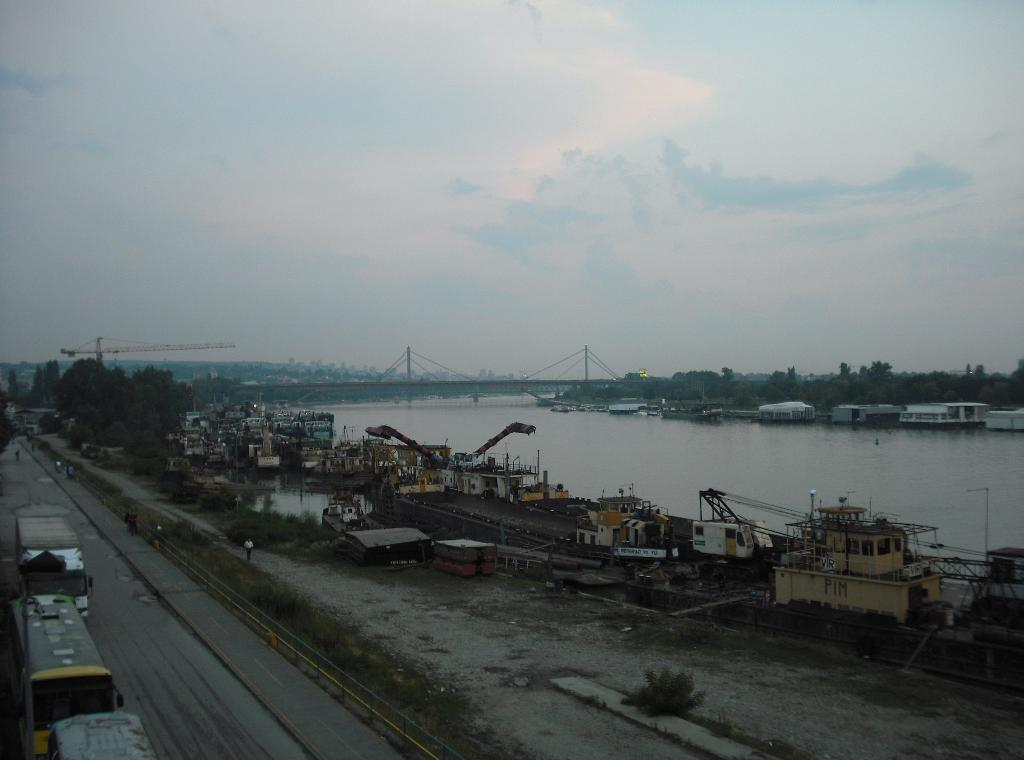What can be seen on the road in the image? There are vehicles on the road in the image. What type of natural environment is visible in the image? There is grass, trees, and water visible in the image. What type of construction equipment is present in the image? There are cranes in the image. What type of cargo containers are present in the image? Containers are present in the image. What type of man-made structures are visible in the image? Poles, a bridge, and ships are present in the image. What is visible in the background of the image? The sky is visible in the background of the image. Can you tell me who won the argument between the cart and the army in the image? There is no cart or army present in the image, and therefore no such argument can be observed. 